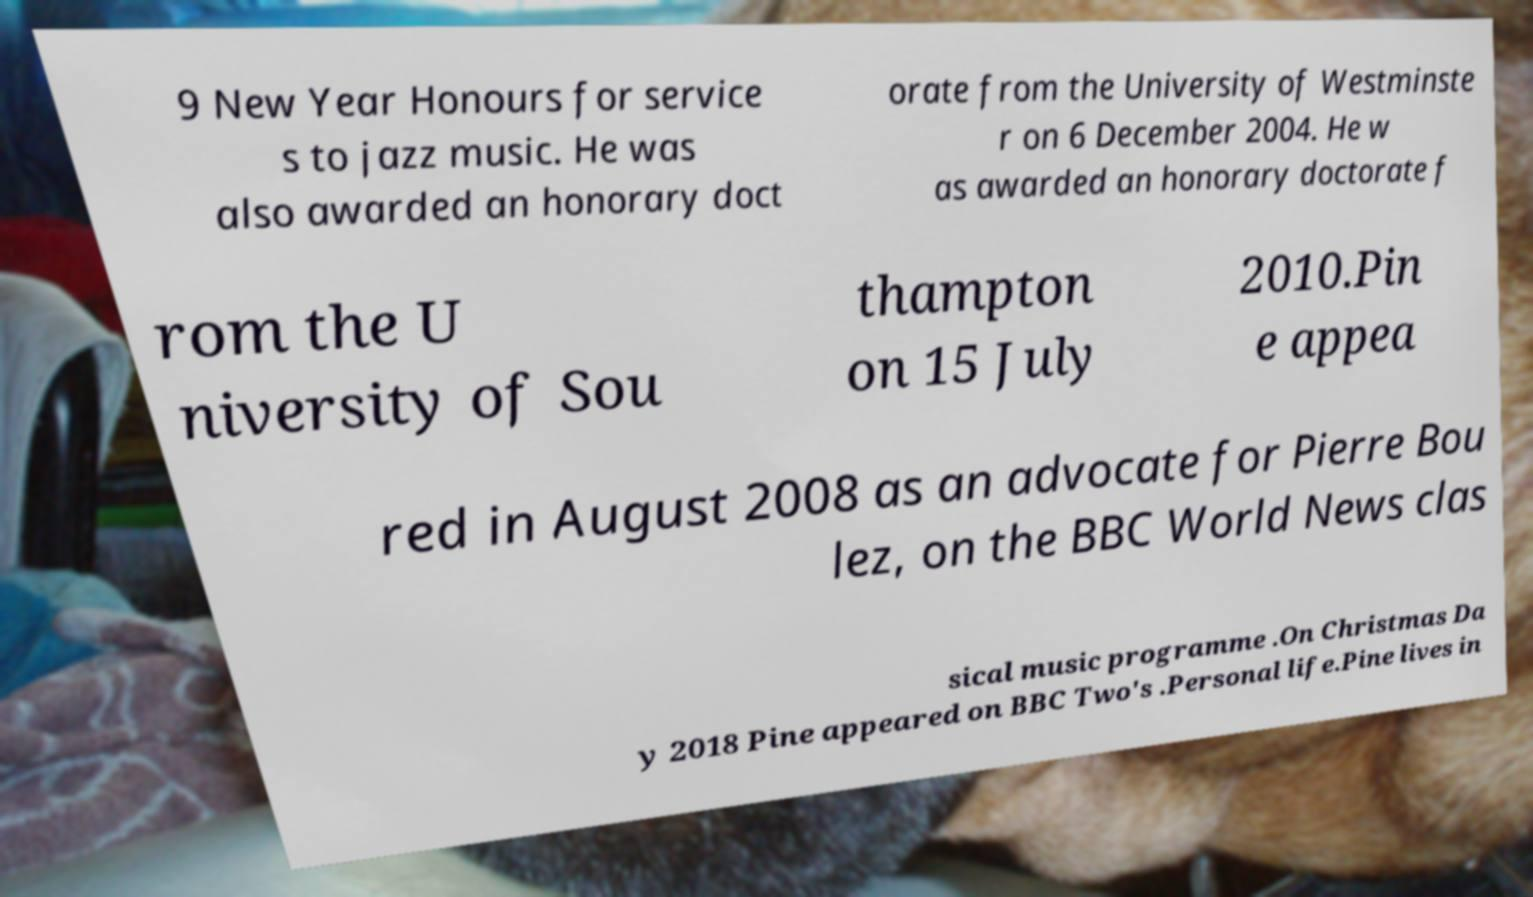What messages or text are displayed in this image? I need them in a readable, typed format. 9 New Year Honours for service s to jazz music. He was also awarded an honorary doct orate from the University of Westminste r on 6 December 2004. He w as awarded an honorary doctorate f rom the U niversity of Sou thampton on 15 July 2010.Pin e appea red in August 2008 as an advocate for Pierre Bou lez, on the BBC World News clas sical music programme .On Christmas Da y 2018 Pine appeared on BBC Two's .Personal life.Pine lives in 